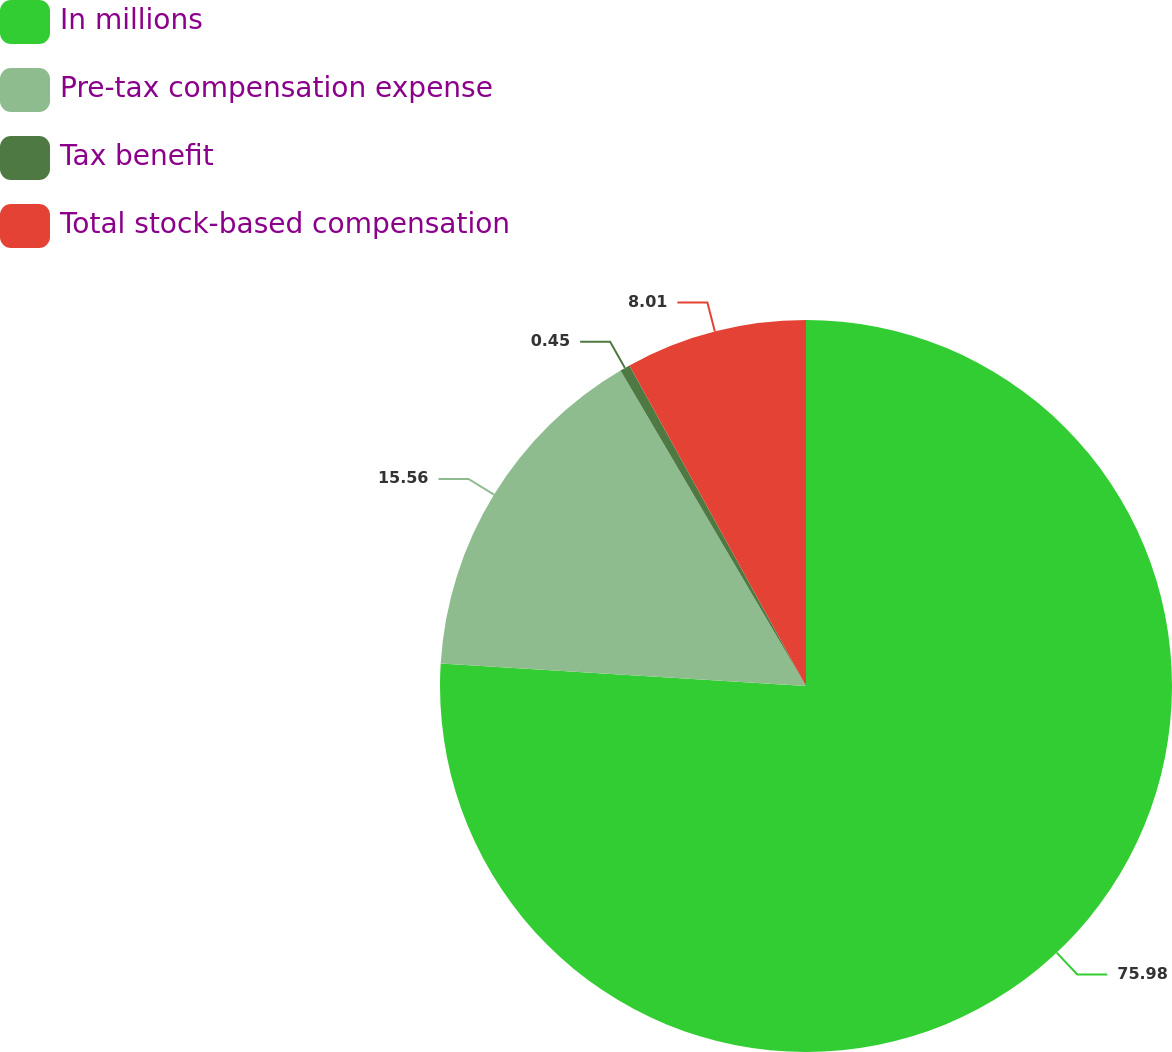Convert chart. <chart><loc_0><loc_0><loc_500><loc_500><pie_chart><fcel>In millions<fcel>Pre-tax compensation expense<fcel>Tax benefit<fcel>Total stock-based compensation<nl><fcel>75.98%<fcel>15.56%<fcel>0.45%<fcel>8.01%<nl></chart> 